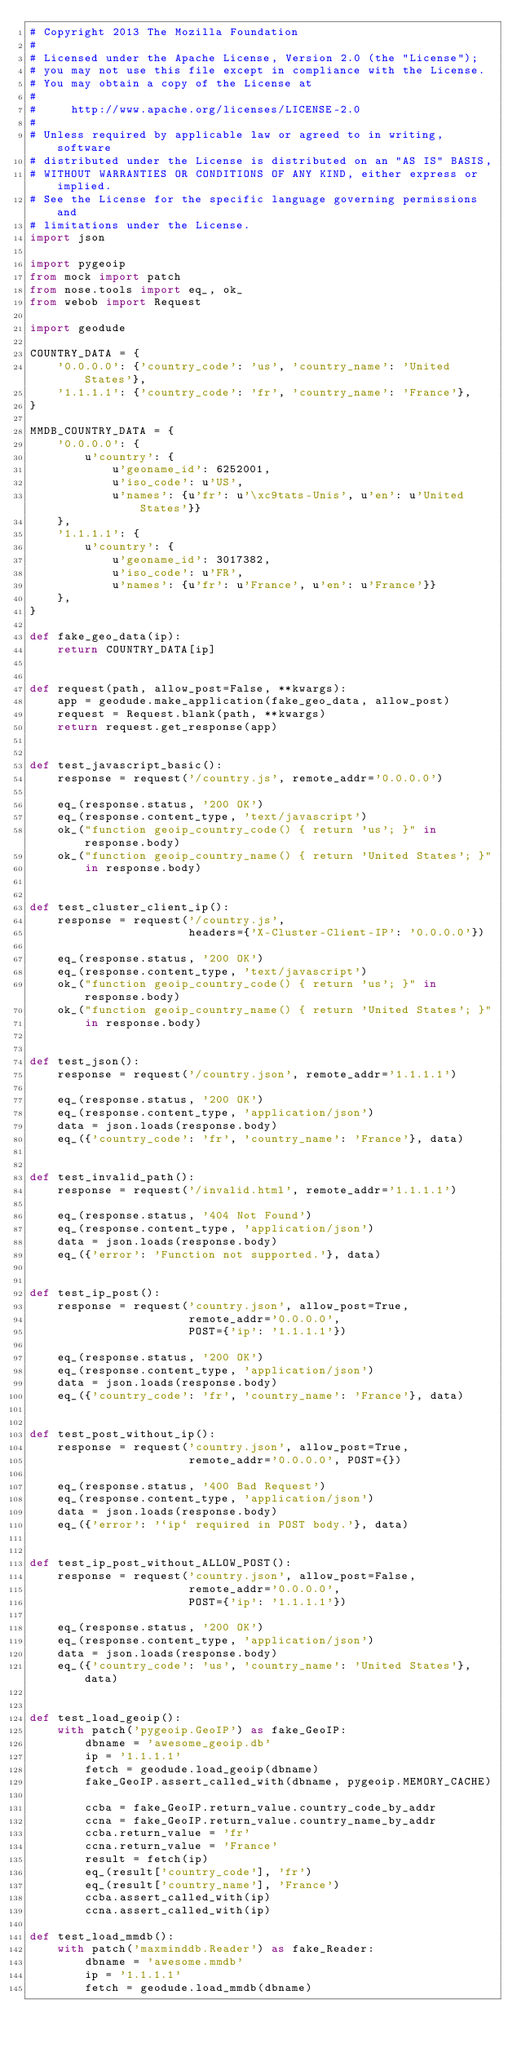Convert code to text. <code><loc_0><loc_0><loc_500><loc_500><_Python_># Copyright 2013 The Mozilla Foundation
#
# Licensed under the Apache License, Version 2.0 (the "License");
# you may not use this file except in compliance with the License.
# You may obtain a copy of the License at
#
#     http://www.apache.org/licenses/LICENSE-2.0
#
# Unless required by applicable law or agreed to in writing, software
# distributed under the License is distributed on an "AS IS" BASIS,
# WITHOUT WARRANTIES OR CONDITIONS OF ANY KIND, either express or implied.
# See the License for the specific language governing permissions and
# limitations under the License.
import json

import pygeoip
from mock import patch
from nose.tools import eq_, ok_
from webob import Request

import geodude

COUNTRY_DATA = {
    '0.0.0.0': {'country_code': 'us', 'country_name': 'United States'},
    '1.1.1.1': {'country_code': 'fr', 'country_name': 'France'},
}

MMDB_COUNTRY_DATA = {
    '0.0.0.0': {
        u'country': {
            u'geoname_id': 6252001,
            u'iso_code': u'US',
            u'names': {u'fr': u'\xc9tats-Unis', u'en': u'United States'}}
    },
    '1.1.1.1': {
        u'country': {
            u'geoname_id': 3017382,
            u'iso_code': u'FR',
            u'names': {u'fr': u'France', u'en': u'France'}}
    },
}

def fake_geo_data(ip):
    return COUNTRY_DATA[ip]


def request(path, allow_post=False, **kwargs):
    app = geodude.make_application(fake_geo_data, allow_post)
    request = Request.blank(path, **kwargs)
    return request.get_response(app)


def test_javascript_basic():
    response = request('/country.js', remote_addr='0.0.0.0')

    eq_(response.status, '200 OK')
    eq_(response.content_type, 'text/javascript')
    ok_("function geoip_country_code() { return 'us'; }" in response.body)
    ok_("function geoip_country_name() { return 'United States'; }"
        in response.body)


def test_cluster_client_ip():
    response = request('/country.js',
                       headers={'X-Cluster-Client-IP': '0.0.0.0'})

    eq_(response.status, '200 OK')
    eq_(response.content_type, 'text/javascript')
    ok_("function geoip_country_code() { return 'us'; }" in response.body)
    ok_("function geoip_country_name() { return 'United States'; }"
        in response.body)


def test_json():
    response = request('/country.json', remote_addr='1.1.1.1')

    eq_(response.status, '200 OK')
    eq_(response.content_type, 'application/json')
    data = json.loads(response.body)
    eq_({'country_code': 'fr', 'country_name': 'France'}, data)


def test_invalid_path():
    response = request('/invalid.html', remote_addr='1.1.1.1')

    eq_(response.status, '404 Not Found')
    eq_(response.content_type, 'application/json')
    data = json.loads(response.body)
    eq_({'error': 'Function not supported.'}, data)


def test_ip_post():
    response = request('country.json', allow_post=True,
                       remote_addr='0.0.0.0',
                       POST={'ip': '1.1.1.1'})

    eq_(response.status, '200 OK')
    eq_(response.content_type, 'application/json')
    data = json.loads(response.body)
    eq_({'country_code': 'fr', 'country_name': 'France'}, data)


def test_post_without_ip():
    response = request('country.json', allow_post=True,
                       remote_addr='0.0.0.0', POST={})

    eq_(response.status, '400 Bad Request')
    eq_(response.content_type, 'application/json')
    data = json.loads(response.body)
    eq_({'error': '`ip` required in POST body.'}, data)


def test_ip_post_without_ALLOW_POST():
    response = request('country.json', allow_post=False,
                       remote_addr='0.0.0.0',
                       POST={'ip': '1.1.1.1'})

    eq_(response.status, '200 OK')
    eq_(response.content_type, 'application/json')
    data = json.loads(response.body)
    eq_({'country_code': 'us', 'country_name': 'United States'}, data)


def test_load_geoip():
    with patch('pygeoip.GeoIP') as fake_GeoIP:
        dbname = 'awesome_geoip.db'
        ip = '1.1.1.1'
        fetch = geodude.load_geoip(dbname)
        fake_GeoIP.assert_called_with(dbname, pygeoip.MEMORY_CACHE)

        ccba = fake_GeoIP.return_value.country_code_by_addr
        ccna = fake_GeoIP.return_value.country_name_by_addr
        ccba.return_value = 'fr'
        ccna.return_value = 'France'
        result = fetch(ip)
        eq_(result['country_code'], 'fr')
        eq_(result['country_name'], 'France')
        ccba.assert_called_with(ip)
        ccna.assert_called_with(ip)

def test_load_mmdb():
    with patch('maxminddb.Reader') as fake_Reader:
        dbname = 'awesome.mmdb'
        ip = '1.1.1.1'
        fetch = geodude.load_mmdb(dbname)</code> 